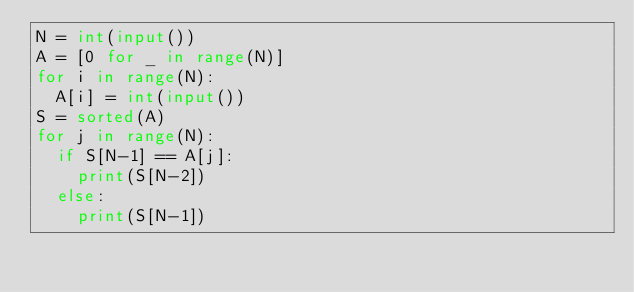Convert code to text. <code><loc_0><loc_0><loc_500><loc_500><_Python_>N = int(input())
A = [0 for _ in range(N)]
for i in range(N):
  A[i] = int(input())
S = sorted(A)  
for j in range(N):
  if S[N-1] == A[j]:
    print(S[N-2])
  else:
    print(S[N-1])</code> 